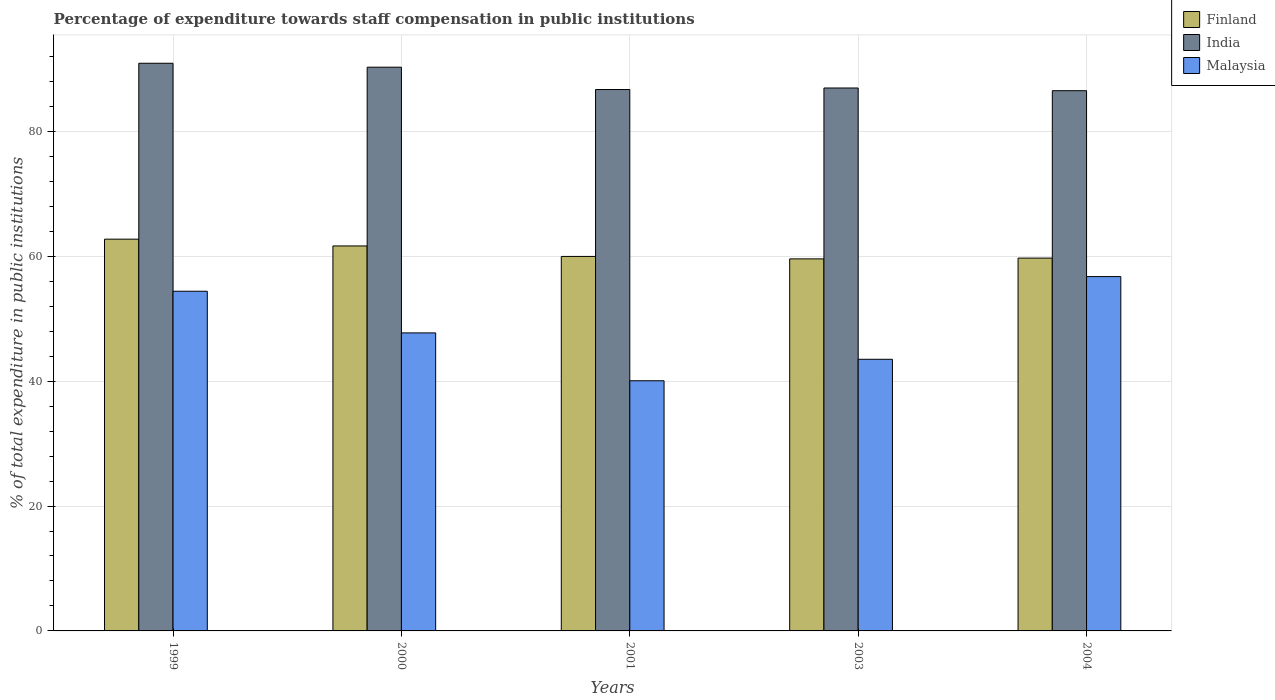How many groups of bars are there?
Offer a very short reply. 5. Are the number of bars on each tick of the X-axis equal?
Ensure brevity in your answer.  Yes. How many bars are there on the 3rd tick from the right?
Your answer should be very brief. 3. In how many cases, is the number of bars for a given year not equal to the number of legend labels?
Offer a terse response. 0. What is the percentage of expenditure towards staff compensation in Finland in 2004?
Offer a very short reply. 59.71. Across all years, what is the maximum percentage of expenditure towards staff compensation in Malaysia?
Provide a short and direct response. 56.75. Across all years, what is the minimum percentage of expenditure towards staff compensation in Malaysia?
Provide a short and direct response. 40.07. In which year was the percentage of expenditure towards staff compensation in India maximum?
Keep it short and to the point. 1999. What is the total percentage of expenditure towards staff compensation in Finland in the graph?
Ensure brevity in your answer.  303.68. What is the difference between the percentage of expenditure towards staff compensation in Malaysia in 2000 and that in 2003?
Your answer should be compact. 4.23. What is the difference between the percentage of expenditure towards staff compensation in India in 2003 and the percentage of expenditure towards staff compensation in Malaysia in 1999?
Make the answer very short. 32.55. What is the average percentage of expenditure towards staff compensation in Finland per year?
Make the answer very short. 60.74. In the year 2003, what is the difference between the percentage of expenditure towards staff compensation in Finland and percentage of expenditure towards staff compensation in Malaysia?
Your answer should be compact. 16.08. What is the ratio of the percentage of expenditure towards staff compensation in Malaysia in 1999 to that in 2001?
Offer a terse response. 1.36. What is the difference between the highest and the second highest percentage of expenditure towards staff compensation in India?
Provide a short and direct response. 0.63. What is the difference between the highest and the lowest percentage of expenditure towards staff compensation in Malaysia?
Provide a succinct answer. 16.69. Is the sum of the percentage of expenditure towards staff compensation in Finland in 2000 and 2004 greater than the maximum percentage of expenditure towards staff compensation in Malaysia across all years?
Offer a terse response. Yes. What does the 1st bar from the left in 2003 represents?
Provide a short and direct response. Finland. What does the 1st bar from the right in 2003 represents?
Offer a very short reply. Malaysia. Are all the bars in the graph horizontal?
Keep it short and to the point. No. How many years are there in the graph?
Your response must be concise. 5. What is the difference between two consecutive major ticks on the Y-axis?
Make the answer very short. 20. What is the title of the graph?
Give a very brief answer. Percentage of expenditure towards staff compensation in public institutions. Does "Guinea" appear as one of the legend labels in the graph?
Your answer should be very brief. No. What is the label or title of the Y-axis?
Make the answer very short. % of total expenditure in public institutions. What is the % of total expenditure in public institutions in Finland in 1999?
Provide a succinct answer. 62.74. What is the % of total expenditure in public institutions in India in 1999?
Ensure brevity in your answer.  90.92. What is the % of total expenditure in public institutions of Malaysia in 1999?
Your answer should be compact. 54.4. What is the % of total expenditure in public institutions of Finland in 2000?
Provide a short and direct response. 61.66. What is the % of total expenditure in public institutions in India in 2000?
Ensure brevity in your answer.  90.29. What is the % of total expenditure in public institutions of Malaysia in 2000?
Keep it short and to the point. 47.73. What is the % of total expenditure in public institutions in Finland in 2001?
Provide a short and direct response. 59.98. What is the % of total expenditure in public institutions in India in 2001?
Provide a short and direct response. 86.71. What is the % of total expenditure in public institutions of Malaysia in 2001?
Provide a short and direct response. 40.07. What is the % of total expenditure in public institutions in Finland in 2003?
Provide a succinct answer. 59.59. What is the % of total expenditure in public institutions in India in 2003?
Offer a terse response. 86.95. What is the % of total expenditure in public institutions of Malaysia in 2003?
Your response must be concise. 43.5. What is the % of total expenditure in public institutions of Finland in 2004?
Provide a succinct answer. 59.71. What is the % of total expenditure in public institutions in India in 2004?
Your response must be concise. 86.52. What is the % of total expenditure in public institutions in Malaysia in 2004?
Your answer should be very brief. 56.75. Across all years, what is the maximum % of total expenditure in public institutions of Finland?
Provide a short and direct response. 62.74. Across all years, what is the maximum % of total expenditure in public institutions in India?
Your answer should be very brief. 90.92. Across all years, what is the maximum % of total expenditure in public institutions in Malaysia?
Your answer should be very brief. 56.75. Across all years, what is the minimum % of total expenditure in public institutions in Finland?
Ensure brevity in your answer.  59.59. Across all years, what is the minimum % of total expenditure in public institutions in India?
Offer a very short reply. 86.52. Across all years, what is the minimum % of total expenditure in public institutions of Malaysia?
Provide a succinct answer. 40.07. What is the total % of total expenditure in public institutions of Finland in the graph?
Your answer should be compact. 303.68. What is the total % of total expenditure in public institutions of India in the graph?
Your answer should be compact. 441.39. What is the total % of total expenditure in public institutions of Malaysia in the graph?
Provide a succinct answer. 242.45. What is the difference between the % of total expenditure in public institutions in Finland in 1999 and that in 2000?
Make the answer very short. 1.09. What is the difference between the % of total expenditure in public institutions in India in 1999 and that in 2000?
Provide a succinct answer. 0.63. What is the difference between the % of total expenditure in public institutions in Malaysia in 1999 and that in 2000?
Make the answer very short. 6.67. What is the difference between the % of total expenditure in public institutions in Finland in 1999 and that in 2001?
Your answer should be very brief. 2.77. What is the difference between the % of total expenditure in public institutions in India in 1999 and that in 2001?
Keep it short and to the point. 4.21. What is the difference between the % of total expenditure in public institutions in Malaysia in 1999 and that in 2001?
Offer a terse response. 14.34. What is the difference between the % of total expenditure in public institutions of Finland in 1999 and that in 2003?
Provide a succinct answer. 3.16. What is the difference between the % of total expenditure in public institutions in India in 1999 and that in 2003?
Your answer should be compact. 3.96. What is the difference between the % of total expenditure in public institutions of Malaysia in 1999 and that in 2003?
Ensure brevity in your answer.  10.9. What is the difference between the % of total expenditure in public institutions in Finland in 1999 and that in 2004?
Give a very brief answer. 3.03. What is the difference between the % of total expenditure in public institutions of India in 1999 and that in 2004?
Your answer should be compact. 4.39. What is the difference between the % of total expenditure in public institutions in Malaysia in 1999 and that in 2004?
Offer a terse response. -2.35. What is the difference between the % of total expenditure in public institutions of Finland in 2000 and that in 2001?
Provide a succinct answer. 1.68. What is the difference between the % of total expenditure in public institutions in India in 2000 and that in 2001?
Provide a short and direct response. 3.58. What is the difference between the % of total expenditure in public institutions of Malaysia in 2000 and that in 2001?
Your answer should be very brief. 7.67. What is the difference between the % of total expenditure in public institutions of Finland in 2000 and that in 2003?
Provide a short and direct response. 2.07. What is the difference between the % of total expenditure in public institutions in India in 2000 and that in 2003?
Make the answer very short. 3.33. What is the difference between the % of total expenditure in public institutions of Malaysia in 2000 and that in 2003?
Keep it short and to the point. 4.23. What is the difference between the % of total expenditure in public institutions of Finland in 2000 and that in 2004?
Provide a short and direct response. 1.95. What is the difference between the % of total expenditure in public institutions of India in 2000 and that in 2004?
Offer a very short reply. 3.76. What is the difference between the % of total expenditure in public institutions of Malaysia in 2000 and that in 2004?
Your response must be concise. -9.02. What is the difference between the % of total expenditure in public institutions of Finland in 2001 and that in 2003?
Provide a succinct answer. 0.39. What is the difference between the % of total expenditure in public institutions of India in 2001 and that in 2003?
Your answer should be compact. -0.24. What is the difference between the % of total expenditure in public institutions of Malaysia in 2001 and that in 2003?
Provide a short and direct response. -3.44. What is the difference between the % of total expenditure in public institutions in Finland in 2001 and that in 2004?
Offer a terse response. 0.27. What is the difference between the % of total expenditure in public institutions in India in 2001 and that in 2004?
Give a very brief answer. 0.19. What is the difference between the % of total expenditure in public institutions in Malaysia in 2001 and that in 2004?
Provide a short and direct response. -16.69. What is the difference between the % of total expenditure in public institutions of Finland in 2003 and that in 2004?
Ensure brevity in your answer.  -0.12. What is the difference between the % of total expenditure in public institutions of India in 2003 and that in 2004?
Provide a short and direct response. 0.43. What is the difference between the % of total expenditure in public institutions in Malaysia in 2003 and that in 2004?
Provide a short and direct response. -13.25. What is the difference between the % of total expenditure in public institutions in Finland in 1999 and the % of total expenditure in public institutions in India in 2000?
Give a very brief answer. -27.54. What is the difference between the % of total expenditure in public institutions in Finland in 1999 and the % of total expenditure in public institutions in Malaysia in 2000?
Keep it short and to the point. 15.01. What is the difference between the % of total expenditure in public institutions in India in 1999 and the % of total expenditure in public institutions in Malaysia in 2000?
Provide a short and direct response. 43.19. What is the difference between the % of total expenditure in public institutions of Finland in 1999 and the % of total expenditure in public institutions of India in 2001?
Your answer should be very brief. -23.97. What is the difference between the % of total expenditure in public institutions in Finland in 1999 and the % of total expenditure in public institutions in Malaysia in 2001?
Your answer should be compact. 22.68. What is the difference between the % of total expenditure in public institutions of India in 1999 and the % of total expenditure in public institutions of Malaysia in 2001?
Your answer should be very brief. 50.85. What is the difference between the % of total expenditure in public institutions in Finland in 1999 and the % of total expenditure in public institutions in India in 2003?
Offer a terse response. -24.21. What is the difference between the % of total expenditure in public institutions of Finland in 1999 and the % of total expenditure in public institutions of Malaysia in 2003?
Offer a very short reply. 19.24. What is the difference between the % of total expenditure in public institutions of India in 1999 and the % of total expenditure in public institutions of Malaysia in 2003?
Make the answer very short. 47.41. What is the difference between the % of total expenditure in public institutions of Finland in 1999 and the % of total expenditure in public institutions of India in 2004?
Offer a terse response. -23.78. What is the difference between the % of total expenditure in public institutions in Finland in 1999 and the % of total expenditure in public institutions in Malaysia in 2004?
Offer a terse response. 5.99. What is the difference between the % of total expenditure in public institutions of India in 1999 and the % of total expenditure in public institutions of Malaysia in 2004?
Offer a very short reply. 34.17. What is the difference between the % of total expenditure in public institutions of Finland in 2000 and the % of total expenditure in public institutions of India in 2001?
Your answer should be compact. -25.05. What is the difference between the % of total expenditure in public institutions in Finland in 2000 and the % of total expenditure in public institutions in Malaysia in 2001?
Keep it short and to the point. 21.59. What is the difference between the % of total expenditure in public institutions in India in 2000 and the % of total expenditure in public institutions in Malaysia in 2001?
Your answer should be compact. 50.22. What is the difference between the % of total expenditure in public institutions in Finland in 2000 and the % of total expenditure in public institutions in India in 2003?
Your answer should be very brief. -25.3. What is the difference between the % of total expenditure in public institutions of Finland in 2000 and the % of total expenditure in public institutions of Malaysia in 2003?
Provide a short and direct response. 18.15. What is the difference between the % of total expenditure in public institutions of India in 2000 and the % of total expenditure in public institutions of Malaysia in 2003?
Provide a short and direct response. 46.78. What is the difference between the % of total expenditure in public institutions of Finland in 2000 and the % of total expenditure in public institutions of India in 2004?
Ensure brevity in your answer.  -24.86. What is the difference between the % of total expenditure in public institutions in Finland in 2000 and the % of total expenditure in public institutions in Malaysia in 2004?
Provide a succinct answer. 4.91. What is the difference between the % of total expenditure in public institutions in India in 2000 and the % of total expenditure in public institutions in Malaysia in 2004?
Your answer should be compact. 33.54. What is the difference between the % of total expenditure in public institutions in Finland in 2001 and the % of total expenditure in public institutions in India in 2003?
Keep it short and to the point. -26.98. What is the difference between the % of total expenditure in public institutions of Finland in 2001 and the % of total expenditure in public institutions of Malaysia in 2003?
Keep it short and to the point. 16.48. What is the difference between the % of total expenditure in public institutions of India in 2001 and the % of total expenditure in public institutions of Malaysia in 2003?
Your answer should be compact. 43.21. What is the difference between the % of total expenditure in public institutions of Finland in 2001 and the % of total expenditure in public institutions of India in 2004?
Give a very brief answer. -26.54. What is the difference between the % of total expenditure in public institutions of Finland in 2001 and the % of total expenditure in public institutions of Malaysia in 2004?
Your answer should be very brief. 3.23. What is the difference between the % of total expenditure in public institutions of India in 2001 and the % of total expenditure in public institutions of Malaysia in 2004?
Ensure brevity in your answer.  29.96. What is the difference between the % of total expenditure in public institutions in Finland in 2003 and the % of total expenditure in public institutions in India in 2004?
Your answer should be very brief. -26.94. What is the difference between the % of total expenditure in public institutions in Finland in 2003 and the % of total expenditure in public institutions in Malaysia in 2004?
Ensure brevity in your answer.  2.84. What is the difference between the % of total expenditure in public institutions in India in 2003 and the % of total expenditure in public institutions in Malaysia in 2004?
Your answer should be very brief. 30.2. What is the average % of total expenditure in public institutions of Finland per year?
Offer a terse response. 60.74. What is the average % of total expenditure in public institutions in India per year?
Your response must be concise. 88.28. What is the average % of total expenditure in public institutions in Malaysia per year?
Give a very brief answer. 48.49. In the year 1999, what is the difference between the % of total expenditure in public institutions in Finland and % of total expenditure in public institutions in India?
Ensure brevity in your answer.  -28.17. In the year 1999, what is the difference between the % of total expenditure in public institutions of Finland and % of total expenditure in public institutions of Malaysia?
Give a very brief answer. 8.34. In the year 1999, what is the difference between the % of total expenditure in public institutions of India and % of total expenditure in public institutions of Malaysia?
Your answer should be compact. 36.52. In the year 2000, what is the difference between the % of total expenditure in public institutions of Finland and % of total expenditure in public institutions of India?
Ensure brevity in your answer.  -28.63. In the year 2000, what is the difference between the % of total expenditure in public institutions of Finland and % of total expenditure in public institutions of Malaysia?
Ensure brevity in your answer.  13.93. In the year 2000, what is the difference between the % of total expenditure in public institutions of India and % of total expenditure in public institutions of Malaysia?
Your response must be concise. 42.55. In the year 2001, what is the difference between the % of total expenditure in public institutions of Finland and % of total expenditure in public institutions of India?
Keep it short and to the point. -26.73. In the year 2001, what is the difference between the % of total expenditure in public institutions in Finland and % of total expenditure in public institutions in Malaysia?
Provide a succinct answer. 19.91. In the year 2001, what is the difference between the % of total expenditure in public institutions of India and % of total expenditure in public institutions of Malaysia?
Make the answer very short. 46.65. In the year 2003, what is the difference between the % of total expenditure in public institutions of Finland and % of total expenditure in public institutions of India?
Offer a terse response. -27.37. In the year 2003, what is the difference between the % of total expenditure in public institutions in Finland and % of total expenditure in public institutions in Malaysia?
Provide a short and direct response. 16.08. In the year 2003, what is the difference between the % of total expenditure in public institutions in India and % of total expenditure in public institutions in Malaysia?
Your answer should be compact. 43.45. In the year 2004, what is the difference between the % of total expenditure in public institutions in Finland and % of total expenditure in public institutions in India?
Provide a short and direct response. -26.81. In the year 2004, what is the difference between the % of total expenditure in public institutions in Finland and % of total expenditure in public institutions in Malaysia?
Your answer should be very brief. 2.96. In the year 2004, what is the difference between the % of total expenditure in public institutions of India and % of total expenditure in public institutions of Malaysia?
Your answer should be very brief. 29.77. What is the ratio of the % of total expenditure in public institutions of Finland in 1999 to that in 2000?
Offer a terse response. 1.02. What is the ratio of the % of total expenditure in public institutions of India in 1999 to that in 2000?
Keep it short and to the point. 1.01. What is the ratio of the % of total expenditure in public institutions in Malaysia in 1999 to that in 2000?
Your answer should be very brief. 1.14. What is the ratio of the % of total expenditure in public institutions in Finland in 1999 to that in 2001?
Offer a terse response. 1.05. What is the ratio of the % of total expenditure in public institutions in India in 1999 to that in 2001?
Provide a succinct answer. 1.05. What is the ratio of the % of total expenditure in public institutions of Malaysia in 1999 to that in 2001?
Give a very brief answer. 1.36. What is the ratio of the % of total expenditure in public institutions of Finland in 1999 to that in 2003?
Your answer should be very brief. 1.05. What is the ratio of the % of total expenditure in public institutions of India in 1999 to that in 2003?
Your response must be concise. 1.05. What is the ratio of the % of total expenditure in public institutions in Malaysia in 1999 to that in 2003?
Your answer should be compact. 1.25. What is the ratio of the % of total expenditure in public institutions of Finland in 1999 to that in 2004?
Offer a very short reply. 1.05. What is the ratio of the % of total expenditure in public institutions in India in 1999 to that in 2004?
Your response must be concise. 1.05. What is the ratio of the % of total expenditure in public institutions of Malaysia in 1999 to that in 2004?
Offer a terse response. 0.96. What is the ratio of the % of total expenditure in public institutions of Finland in 2000 to that in 2001?
Ensure brevity in your answer.  1.03. What is the ratio of the % of total expenditure in public institutions of India in 2000 to that in 2001?
Give a very brief answer. 1.04. What is the ratio of the % of total expenditure in public institutions in Malaysia in 2000 to that in 2001?
Your answer should be very brief. 1.19. What is the ratio of the % of total expenditure in public institutions in Finland in 2000 to that in 2003?
Provide a short and direct response. 1.03. What is the ratio of the % of total expenditure in public institutions in India in 2000 to that in 2003?
Give a very brief answer. 1.04. What is the ratio of the % of total expenditure in public institutions of Malaysia in 2000 to that in 2003?
Keep it short and to the point. 1.1. What is the ratio of the % of total expenditure in public institutions in Finland in 2000 to that in 2004?
Offer a terse response. 1.03. What is the ratio of the % of total expenditure in public institutions of India in 2000 to that in 2004?
Give a very brief answer. 1.04. What is the ratio of the % of total expenditure in public institutions in Malaysia in 2000 to that in 2004?
Ensure brevity in your answer.  0.84. What is the ratio of the % of total expenditure in public institutions of Finland in 2001 to that in 2003?
Your answer should be compact. 1.01. What is the ratio of the % of total expenditure in public institutions in Malaysia in 2001 to that in 2003?
Your response must be concise. 0.92. What is the ratio of the % of total expenditure in public institutions in Finland in 2001 to that in 2004?
Make the answer very short. 1. What is the ratio of the % of total expenditure in public institutions of India in 2001 to that in 2004?
Give a very brief answer. 1. What is the ratio of the % of total expenditure in public institutions of Malaysia in 2001 to that in 2004?
Offer a very short reply. 0.71. What is the ratio of the % of total expenditure in public institutions in Finland in 2003 to that in 2004?
Offer a very short reply. 1. What is the ratio of the % of total expenditure in public institutions of Malaysia in 2003 to that in 2004?
Provide a succinct answer. 0.77. What is the difference between the highest and the second highest % of total expenditure in public institutions of Finland?
Your response must be concise. 1.09. What is the difference between the highest and the second highest % of total expenditure in public institutions in India?
Make the answer very short. 0.63. What is the difference between the highest and the second highest % of total expenditure in public institutions of Malaysia?
Offer a very short reply. 2.35. What is the difference between the highest and the lowest % of total expenditure in public institutions in Finland?
Make the answer very short. 3.16. What is the difference between the highest and the lowest % of total expenditure in public institutions in India?
Your response must be concise. 4.39. What is the difference between the highest and the lowest % of total expenditure in public institutions in Malaysia?
Your answer should be compact. 16.69. 